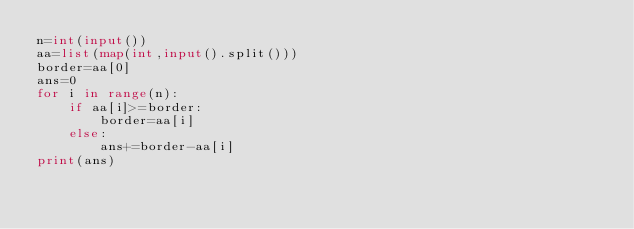<code> <loc_0><loc_0><loc_500><loc_500><_Python_>n=int(input())
aa=list(map(int,input().split()))
border=aa[0]
ans=0
for i in range(n):
    if aa[i]>=border:
        border=aa[i]
    else:
        ans+=border-aa[i]
print(ans)
</code> 